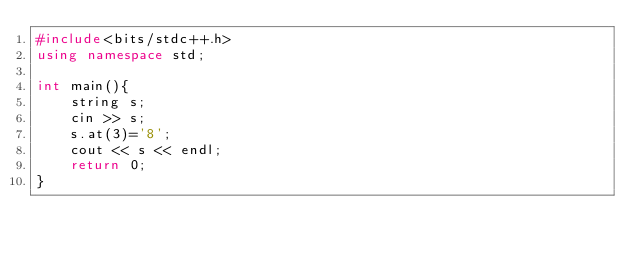<code> <loc_0><loc_0><loc_500><loc_500><_C++_>#include<bits/stdc++.h>
using namespace std;

int main(){
    string s;
    cin >> s;
    s.at(3)='8';
    cout << s << endl;
    return 0;
}</code> 